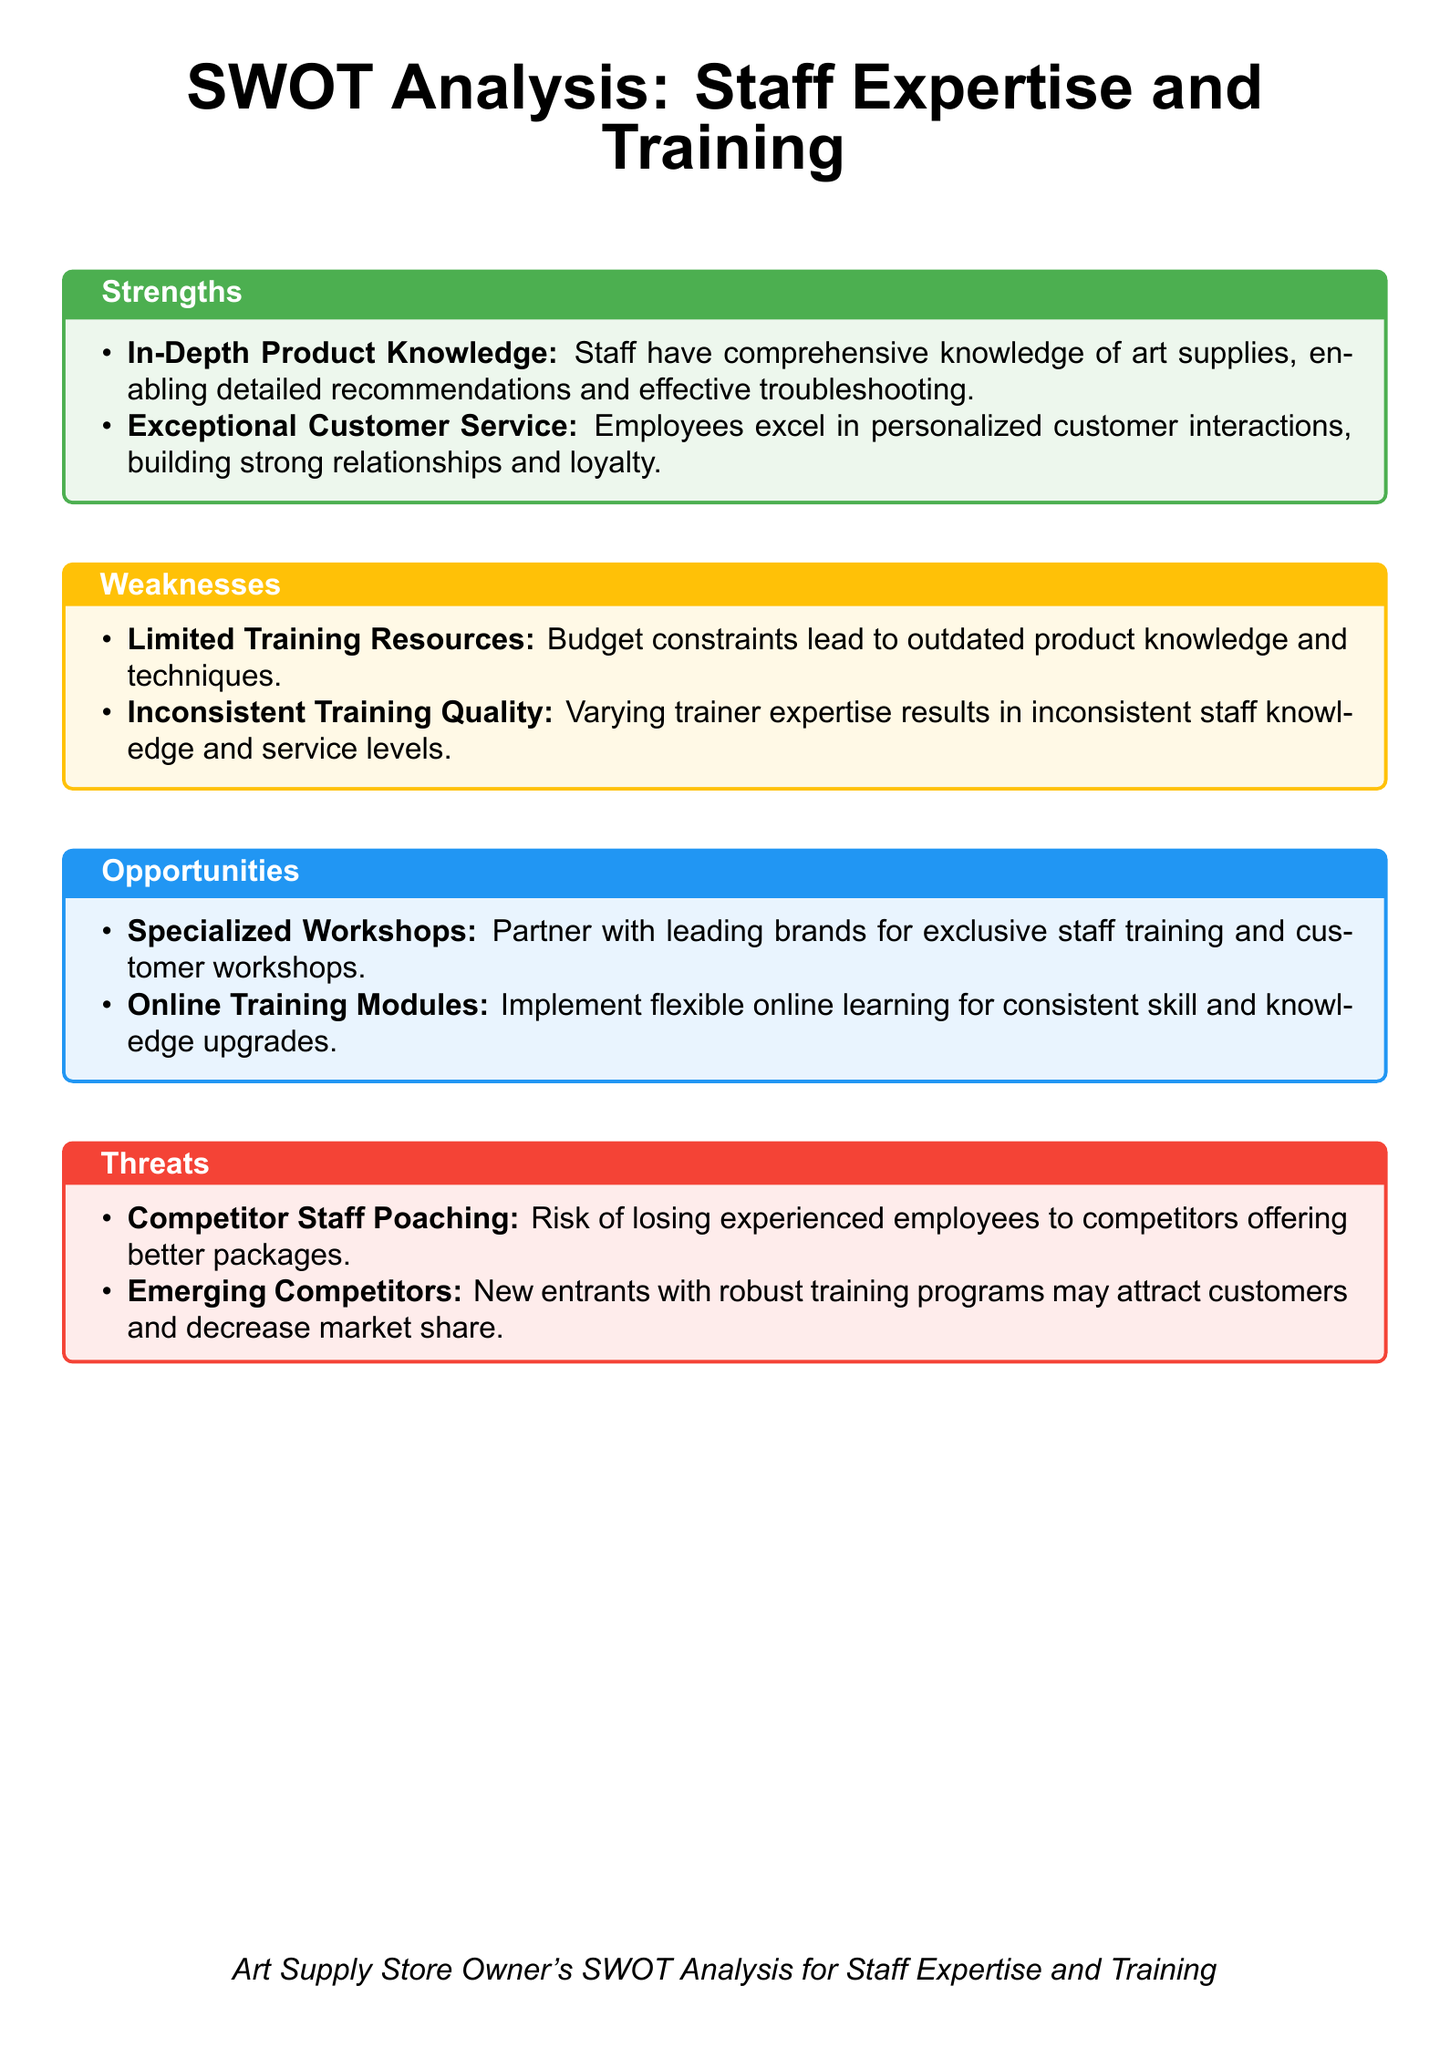What are two strengths of the staff? The strengths listed in the document highlight the staff's in-depth product knowledge and exceptional customer service.
Answer: In-Depth Product Knowledge, Exceptional Customer Service What is a weakness related to training resources? The document states that limited training resources are a weakness due to budget constraints.
Answer: Limited Training Resources What is one opportunity for staff development mentioned? The document suggests specialized workshops as an opportunity for improving staff expertise.
Answer: Specialized Workshops How does competitor staff poaching present a threat? This threat indicates a risk of losing experienced employees to competitors who offer better packages.
Answer: Competitor Staff Poaching What could improve training consistency? The document indicates that implementing online training modules could provide consistent skill upgrades.
Answer: Online Training Modules What is a threat posed by new entrants? The document mentions that emerging competitors with robust training programs could attract customers.
Answer: Emerging Competitors How many strengths are mentioned in the document? The document lists two strengths under the strengths section.
Answer: 2 What does inconsistency in training quality affect? The document suggests that varying trainer expertise results in inconsistent staff knowledge and service levels.
Answer: Staff knowledge and service levels 